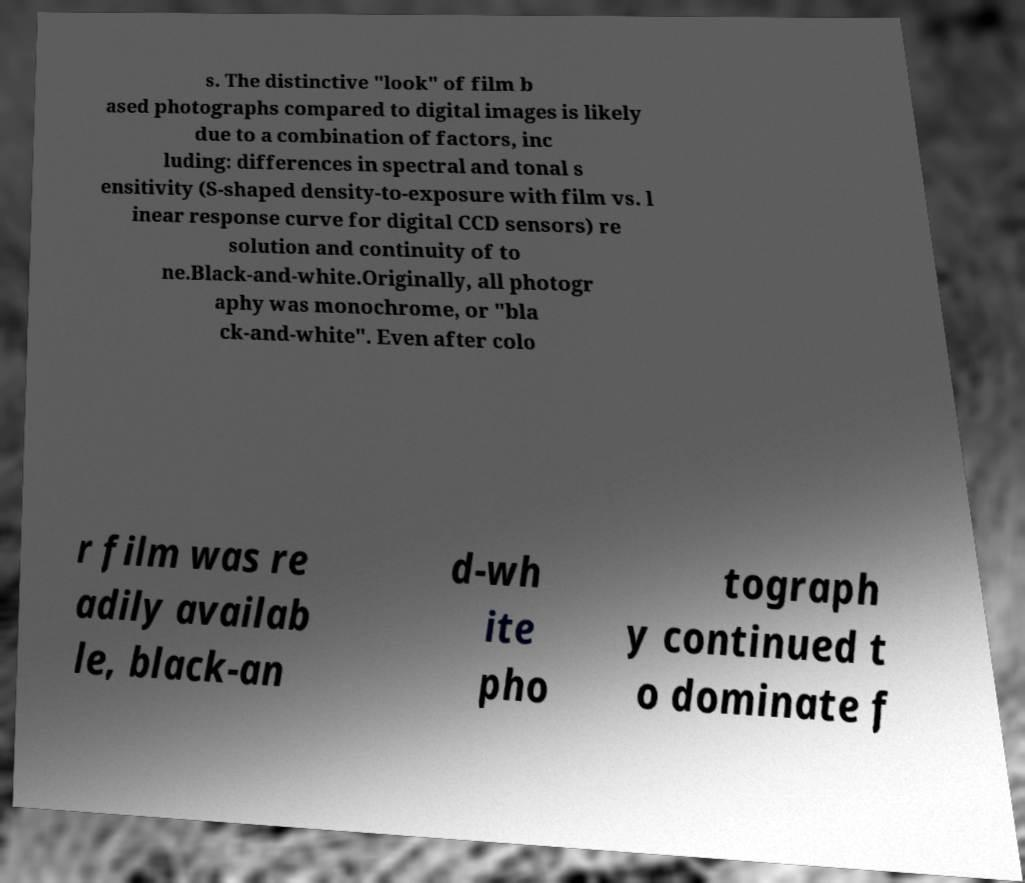What messages or text are displayed in this image? I need them in a readable, typed format. s. The distinctive "look" of film b ased photographs compared to digital images is likely due to a combination of factors, inc luding: differences in spectral and tonal s ensitivity (S-shaped density-to-exposure with film vs. l inear response curve for digital CCD sensors) re solution and continuity of to ne.Black-and-white.Originally, all photogr aphy was monochrome, or "bla ck-and-white". Even after colo r film was re adily availab le, black-an d-wh ite pho tograph y continued t o dominate f 